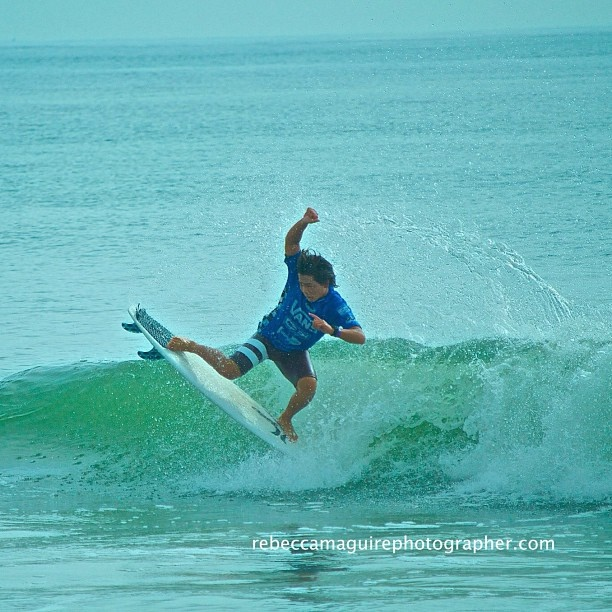Describe the objects in this image and their specific colors. I can see people in lightblue, gray, blue, and darkblue tones and surfboard in lightblue, turquoise, and teal tones in this image. 